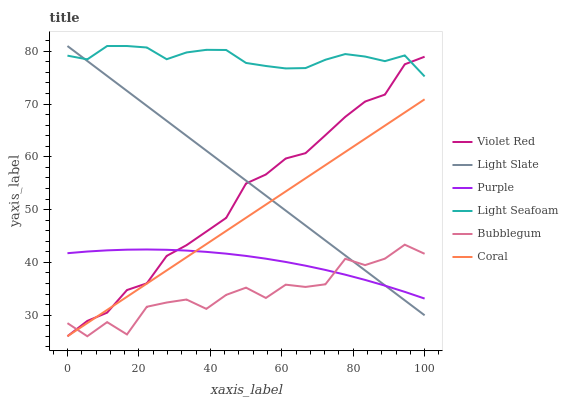Does Bubblegum have the minimum area under the curve?
Answer yes or no. Yes. Does Light Seafoam have the maximum area under the curve?
Answer yes or no. Yes. Does Light Slate have the minimum area under the curve?
Answer yes or no. No. Does Light Slate have the maximum area under the curve?
Answer yes or no. No. Is Light Slate the smoothest?
Answer yes or no. Yes. Is Bubblegum the roughest?
Answer yes or no. Yes. Is Coral the smoothest?
Answer yes or no. No. Is Coral the roughest?
Answer yes or no. No. Does Violet Red have the lowest value?
Answer yes or no. Yes. Does Light Slate have the lowest value?
Answer yes or no. No. Does Light Seafoam have the highest value?
Answer yes or no. Yes. Does Coral have the highest value?
Answer yes or no. No. Is Coral less than Light Seafoam?
Answer yes or no. Yes. Is Light Seafoam greater than Purple?
Answer yes or no. Yes. Does Light Seafoam intersect Violet Red?
Answer yes or no. Yes. Is Light Seafoam less than Violet Red?
Answer yes or no. No. Is Light Seafoam greater than Violet Red?
Answer yes or no. No. Does Coral intersect Light Seafoam?
Answer yes or no. No. 